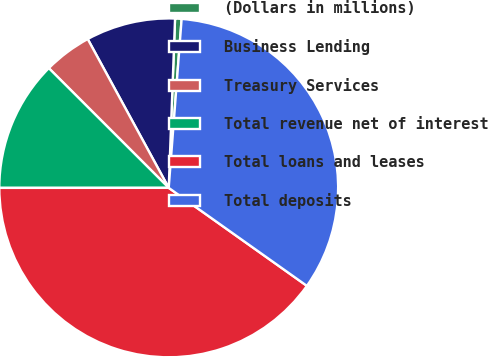<chart> <loc_0><loc_0><loc_500><loc_500><pie_chart><fcel>(Dollars in millions)<fcel>Business Lending<fcel>Treasury Services<fcel>Total revenue net of interest<fcel>Total loans and leases<fcel>Total deposits<nl><fcel>0.62%<fcel>8.53%<fcel>4.58%<fcel>12.49%<fcel>40.18%<fcel>33.61%<nl></chart> 